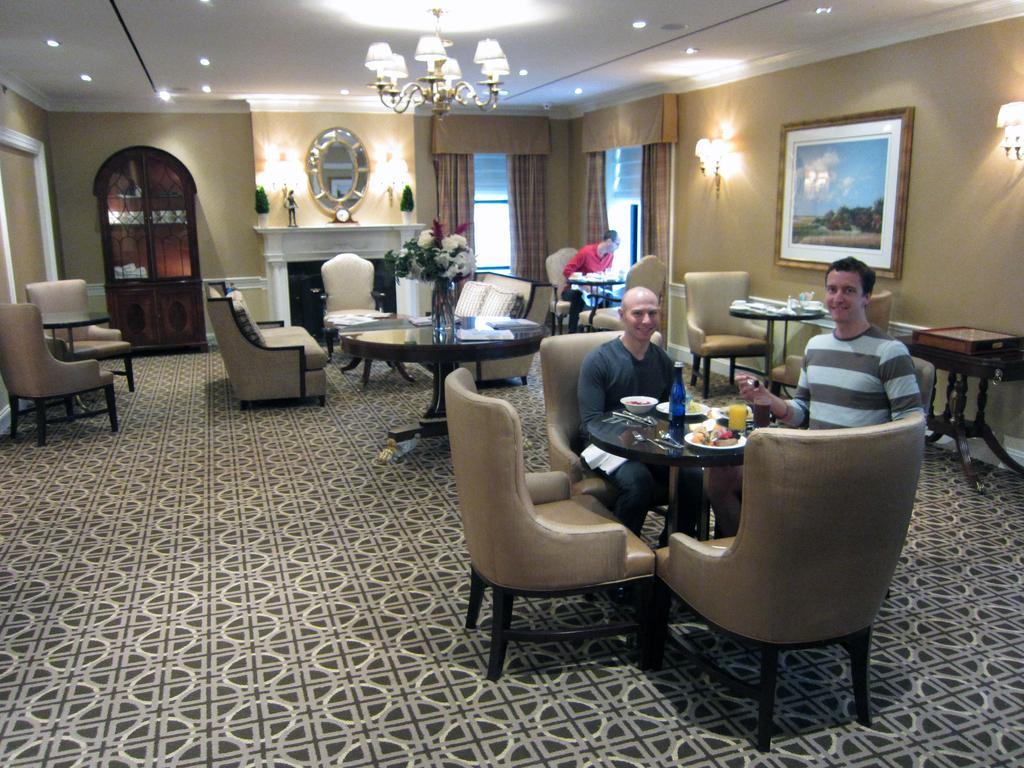Please provide a concise description of this image. This picture is clicked inside a room. The man on the right corner of the picture is holding a spoon in his hand and he is smiling. Beside him, we see a man with black t-shirt is also sitting on the chair and smiling. In front of them, we see a table on which bottle, plate, food, bowl, spoon are placed. In this room, we find many tables and chairs. Behind them, we see a wall and a photo frame on it. Beside that, we see lights and on background, we see man in red shirt sitting on the chair. Behind him, we see windows and curtains and beside that, we see mirror and beside the mirror, we see door which is brown in color. 